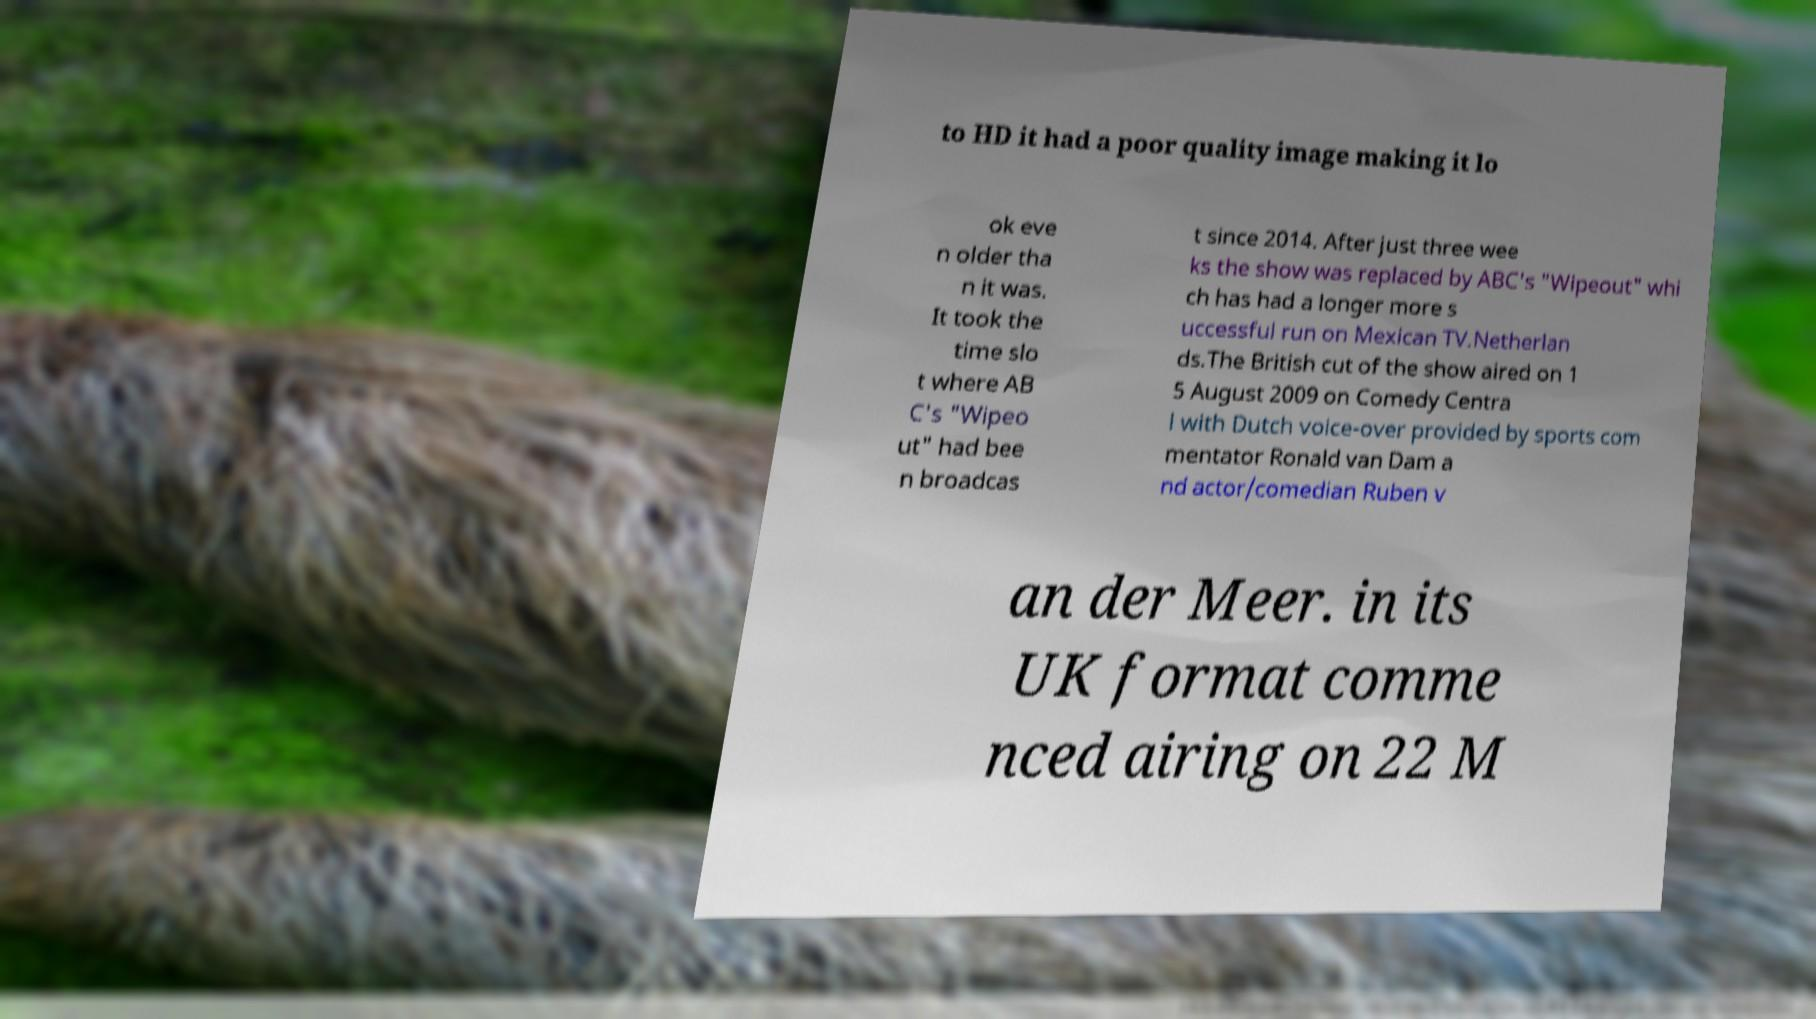There's text embedded in this image that I need extracted. Can you transcribe it verbatim? to HD it had a poor quality image making it lo ok eve n older tha n it was. It took the time slo t where AB C's "Wipeo ut" had bee n broadcas t since 2014. After just three wee ks the show was replaced by ABC's "Wipeout" whi ch has had a longer more s uccessful run on Mexican TV.Netherlan ds.The British cut of the show aired on 1 5 August 2009 on Comedy Centra l with Dutch voice-over provided by sports com mentator Ronald van Dam a nd actor/comedian Ruben v an der Meer. in its UK format comme nced airing on 22 M 